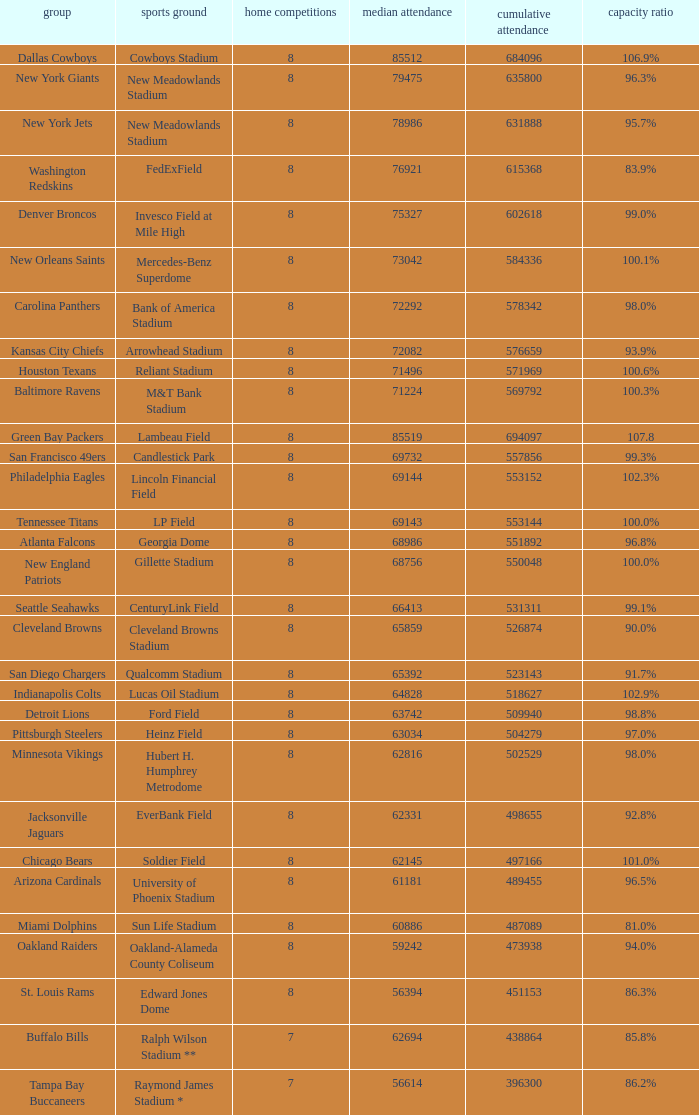How many average attendance has a capacity percentage of 96.5% 1.0. 